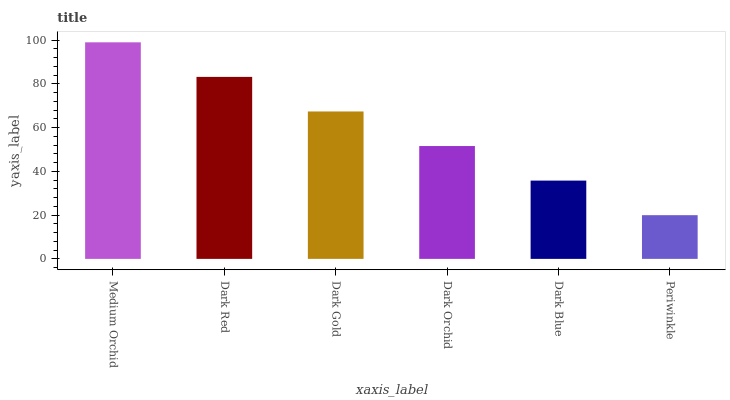Is Dark Red the minimum?
Answer yes or no. No. Is Dark Red the maximum?
Answer yes or no. No. Is Medium Orchid greater than Dark Red?
Answer yes or no. Yes. Is Dark Red less than Medium Orchid?
Answer yes or no. Yes. Is Dark Red greater than Medium Orchid?
Answer yes or no. No. Is Medium Orchid less than Dark Red?
Answer yes or no. No. Is Dark Gold the high median?
Answer yes or no. Yes. Is Dark Orchid the low median?
Answer yes or no. Yes. Is Dark Orchid the high median?
Answer yes or no. No. Is Dark Blue the low median?
Answer yes or no. No. 